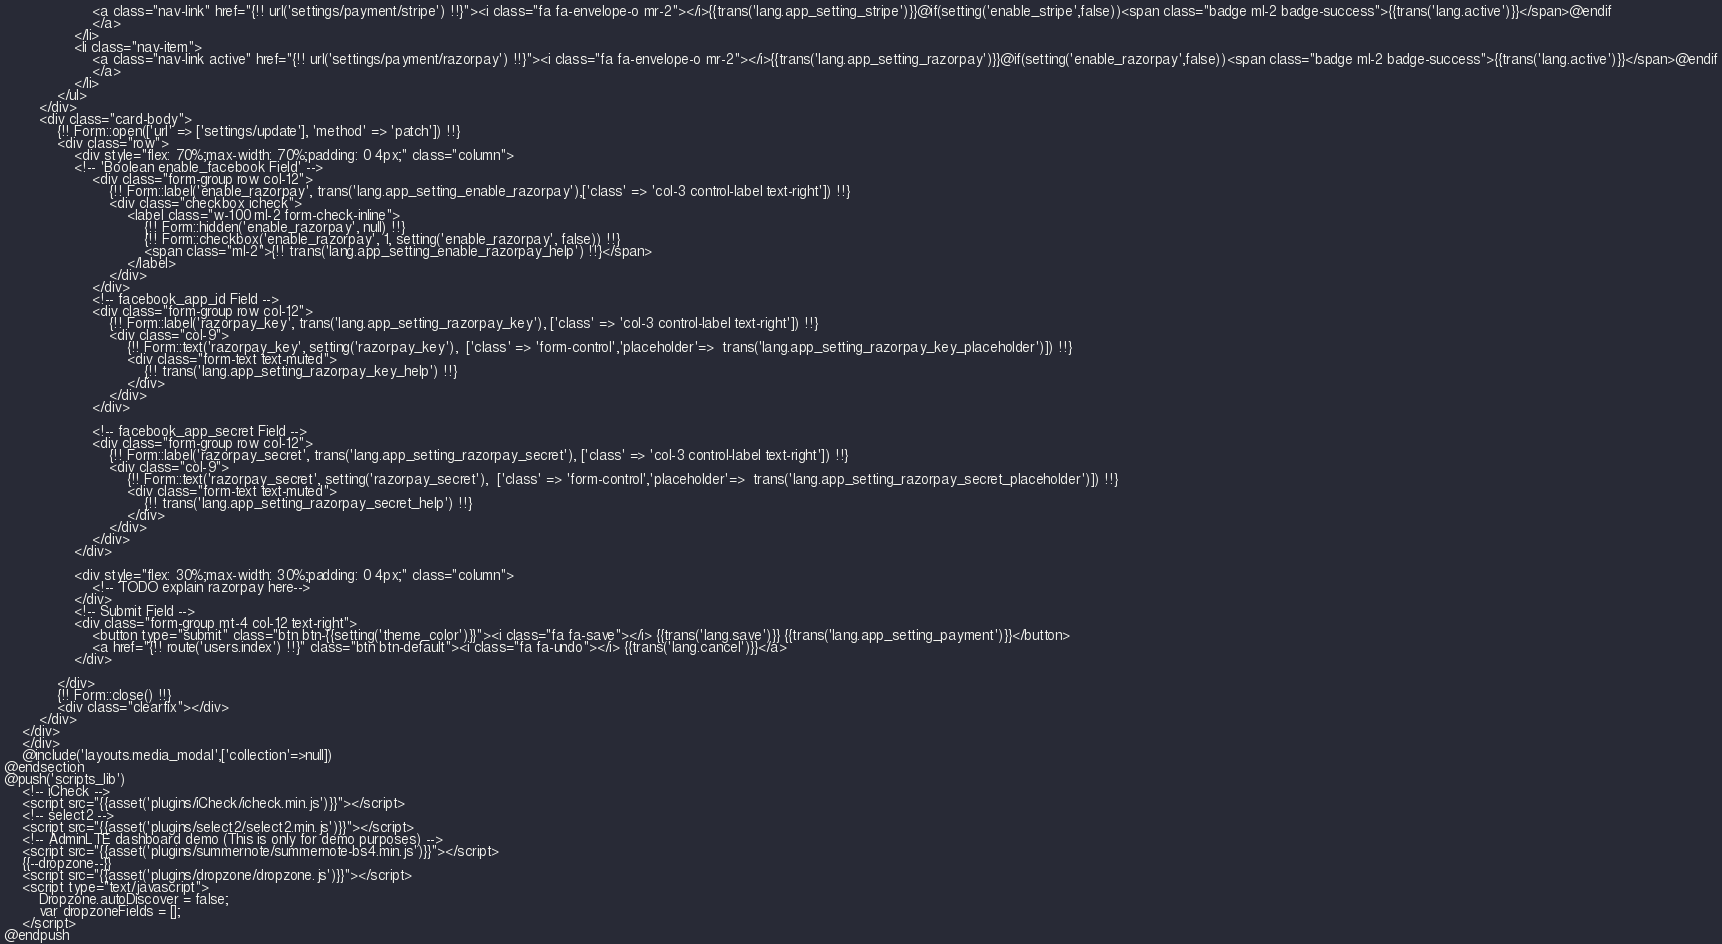Convert code to text. <code><loc_0><loc_0><loc_500><loc_500><_PHP_>                    <a class="nav-link" href="{!! url('settings/payment/stripe') !!}"><i class="fa fa-envelope-o mr-2"></i>{{trans('lang.app_setting_stripe')}}@if(setting('enable_stripe',false))<span class="badge ml-2 badge-success">{{trans('lang.active')}}</span>@endif
                    </a>
                </li>
                <li class="nav-item">
                    <a class="nav-link active" href="{!! url('settings/payment/razorpay') !!}"><i class="fa fa-envelope-o mr-2"></i>{{trans('lang.app_setting_razorpay')}}@if(setting('enable_razorpay',false))<span class="badge ml-2 badge-success">{{trans('lang.active')}}</span>@endif
                    </a>
                </li>
            </ul>
        </div>
        <div class="card-body">
            {!! Form::open(['url' => ['settings/update'], 'method' => 'patch']) !!}
            <div class="row">
                <div style="flex: 70%;max-width: 70%;padding: 0 4px;" class="column">
                <!-- 'Boolean enable_facebook Field' -->
                    <div class="form-group row col-12">
                        {!! Form::label('enable_razorpay', trans('lang.app_setting_enable_razorpay'),['class' => 'col-3 control-label text-right']) !!}
                        <div class="checkbox icheck">
                            <label class="w-100 ml-2 form-check-inline">
                                {!! Form::hidden('enable_razorpay', null) !!}
                                {!! Form::checkbox('enable_razorpay', 1, setting('enable_razorpay', false)) !!}
                                <span class="ml-2">{!! trans('lang.app_setting_enable_razorpay_help') !!}</span>
                            </label>
                        </div>
                    </div>
                    <!-- facebook_app_id Field -->
                    <div class="form-group row col-12">
                        {!! Form::label('razorpay_key', trans('lang.app_setting_razorpay_key'), ['class' => 'col-3 control-label text-right']) !!}
                        <div class="col-9">
                            {!! Form::text('razorpay_key', setting('razorpay_key'),  ['class' => 'form-control','placeholder'=>  trans('lang.app_setting_razorpay_key_placeholder')]) !!}
                            <div class="form-text text-muted">
                                {!! trans('lang.app_setting_razorpay_key_help') !!}
                            </div>
                        </div>
                    </div>

                    <!-- facebook_app_secret Field -->
                    <div class="form-group row col-12">
                        {!! Form::label('razorpay_secret', trans('lang.app_setting_razorpay_secret'), ['class' => 'col-3 control-label text-right']) !!}
                        <div class="col-9">
                            {!! Form::text('razorpay_secret', setting('razorpay_secret'),  ['class' => 'form-control','placeholder'=>  trans('lang.app_setting_razorpay_secret_placeholder')]) !!}
                            <div class="form-text text-muted">
                                {!! trans('lang.app_setting_razorpay_secret_help') !!}
                            </div>
                        </div>
                    </div>
                </div>

                <div style="flex: 30%;max-width: 30%;padding: 0 4px;" class="column">
                    <!-- TODO explain razorpay here-->
                </div>
                <!-- Submit Field -->
                <div class="form-group mt-4 col-12 text-right">
                    <button type="submit" class="btn btn-{{setting('theme_color')}}"><i class="fa fa-save"></i> {{trans('lang.save')}} {{trans('lang.app_setting_payment')}}</button>
                    <a href="{!! route('users.index') !!}" class="btn btn-default"><i class="fa fa-undo"></i> {{trans('lang.cancel')}}</a>
                </div>

            </div>
            {!! Form::close() !!}
            <div class="clearfix"></div>
        </div>
    </div>
    </div>
    @include('layouts.media_modal',['collection'=>null])
@endsection
@push('scripts_lib')
    <!-- iCheck -->
    <script src="{{asset('plugins/iCheck/icheck.min.js')}}"></script>
    <!-- select2 -->
    <script src="{{asset('plugins/select2/select2.min.js')}}"></script>
    <!-- AdminLTE dashboard demo (This is only for demo purposes) -->
    <script src="{{asset('plugins/summernote/summernote-bs4.min.js')}}"></script>
    {{--dropzone--}}
    <script src="{{asset('plugins/dropzone/dropzone.js')}}"></script>
    <script type="text/javascript">
        Dropzone.autoDiscover = false;
        var dropzoneFields = [];
    </script>
@endpush
</code> 